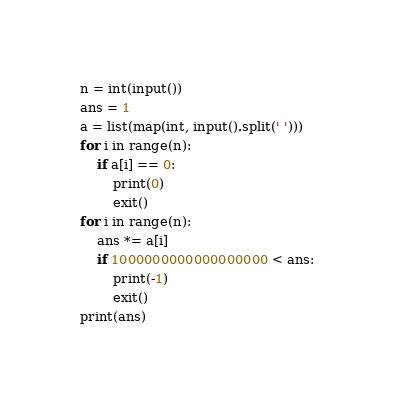<code> <loc_0><loc_0><loc_500><loc_500><_Python_>n = int(input())
ans = 1
a = list(map(int, input().split(' ')))
for i in range(n):
    if a[i] == 0:
        print(0)
        exit()
for i in range(n):
    ans *= a[i]
    if 1000000000000000000 < ans:
        print(-1)
        exit()
print(ans)
</code> 